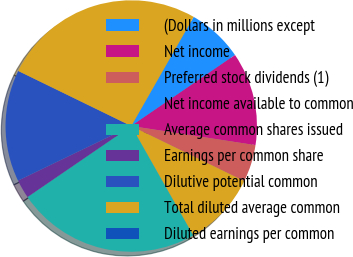Convert chart. <chart><loc_0><loc_0><loc_500><loc_500><pie_chart><fcel>(Dollars in millions except<fcel>Net income<fcel>Preferred stock dividends (1)<fcel>Net income available to common<fcel>Average common shares issued<fcel>Earnings per common share<fcel>Dilutive potential common<fcel>Total diluted average common<fcel>Diluted earnings per common<nl><fcel>7.19%<fcel>11.98%<fcel>4.79%<fcel>9.58%<fcel>23.65%<fcel>2.4%<fcel>14.37%<fcel>26.05%<fcel>0.0%<nl></chart> 